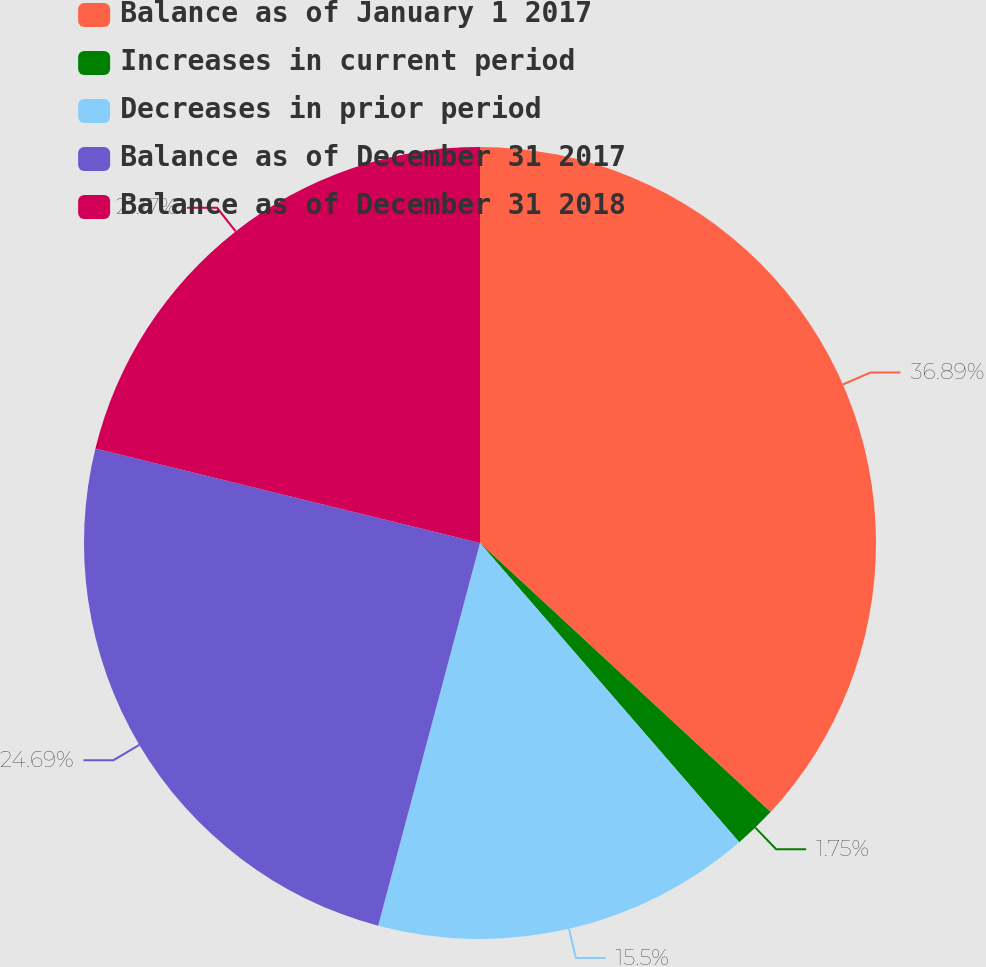Convert chart to OTSL. <chart><loc_0><loc_0><loc_500><loc_500><pie_chart><fcel>Balance as of January 1 2017<fcel>Increases in current period<fcel>Decreases in prior period<fcel>Balance as of December 31 2017<fcel>Balance as of December 31 2018<nl><fcel>36.89%<fcel>1.75%<fcel>15.5%<fcel>24.69%<fcel>21.17%<nl></chart> 